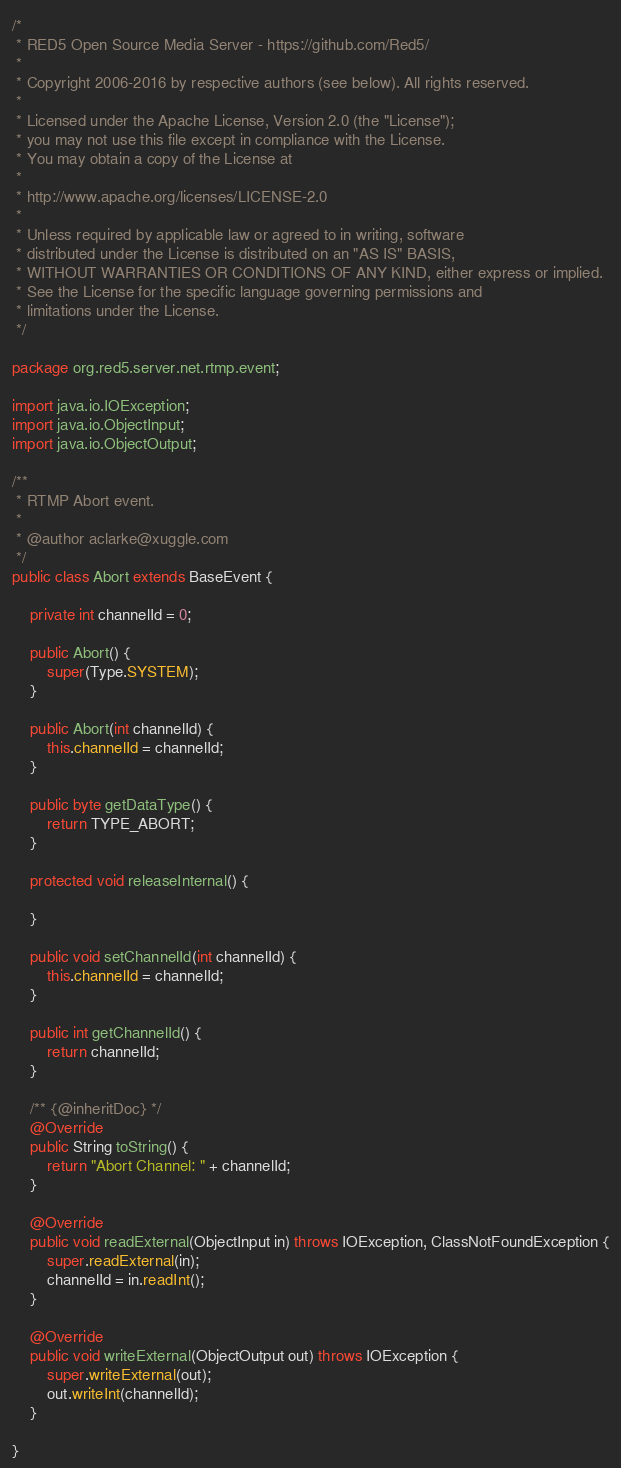<code> <loc_0><loc_0><loc_500><loc_500><_Java_>/*
 * RED5 Open Source Media Server - https://github.com/Red5/
 * 
 * Copyright 2006-2016 by respective authors (see below). All rights reserved.
 * 
 * Licensed under the Apache License, Version 2.0 (the "License");
 * you may not use this file except in compliance with the License.
 * You may obtain a copy of the License at
 * 
 * http://www.apache.org/licenses/LICENSE-2.0
 * 
 * Unless required by applicable law or agreed to in writing, software
 * distributed under the License is distributed on an "AS IS" BASIS,
 * WITHOUT WARRANTIES OR CONDITIONS OF ANY KIND, either express or implied.
 * See the License for the specific language governing permissions and
 * limitations under the License.
 */

package org.red5.server.net.rtmp.event;

import java.io.IOException;
import java.io.ObjectInput;
import java.io.ObjectOutput;

/**
 * RTMP Abort event.
 * 
 * @author aclarke@xuggle.com
 */
public class Abort extends BaseEvent {

    private int channelId = 0;

    public Abort() {
        super(Type.SYSTEM);
    }

    public Abort(int channelId) {
        this.channelId = channelId;
    }

    public byte getDataType() {
        return TYPE_ABORT;
    }

    protected void releaseInternal() {

    }

    public void setChannelId(int channelId) {
        this.channelId = channelId;
    }

    public int getChannelId() {
        return channelId;
    }

    /** {@inheritDoc} */
    @Override
    public String toString() {
        return "Abort Channel: " + channelId;
    }

    @Override
    public void readExternal(ObjectInput in) throws IOException, ClassNotFoundException {
        super.readExternal(in);
        channelId = in.readInt();
    }

    @Override
    public void writeExternal(ObjectOutput out) throws IOException {
        super.writeExternal(out);
        out.writeInt(channelId);
    }

}</code> 